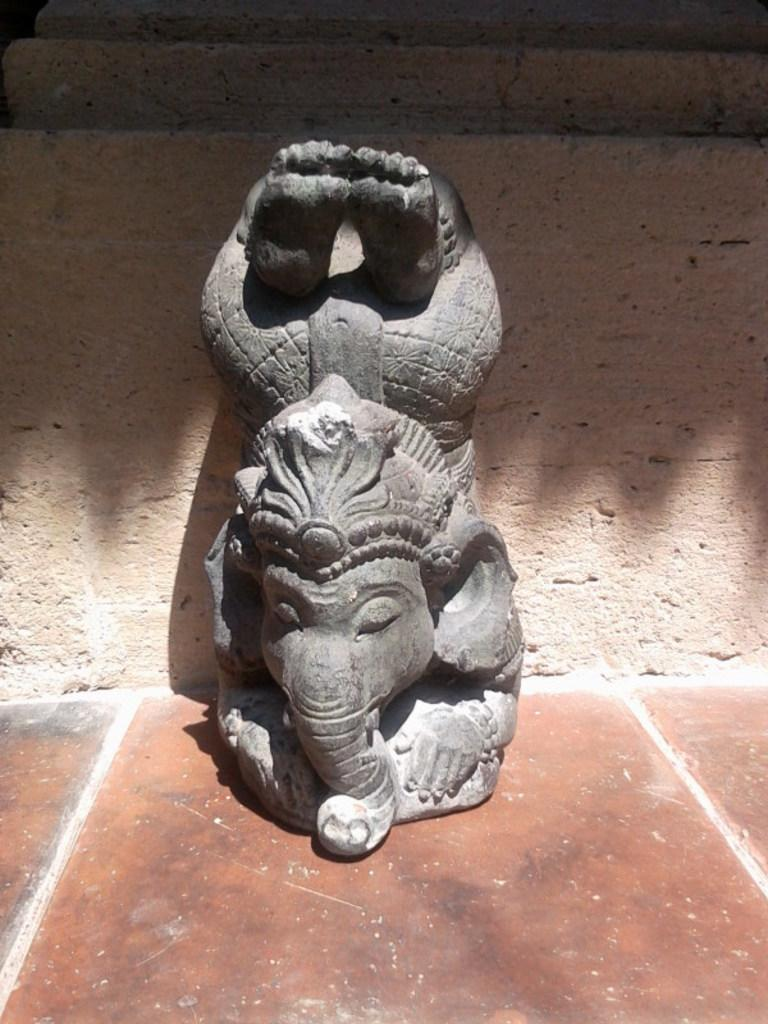What is the main subject in the center of the image? There is a sculpture of an object in the center of the image. Where is the sculpture located? The sculpture is placed on the ground. What can be seen in the background of the image? There is an object in the background that appears to be a wall. What day is it according to the calendar in the image? There is no calendar present in the image, so it is not possible to determine the day. 